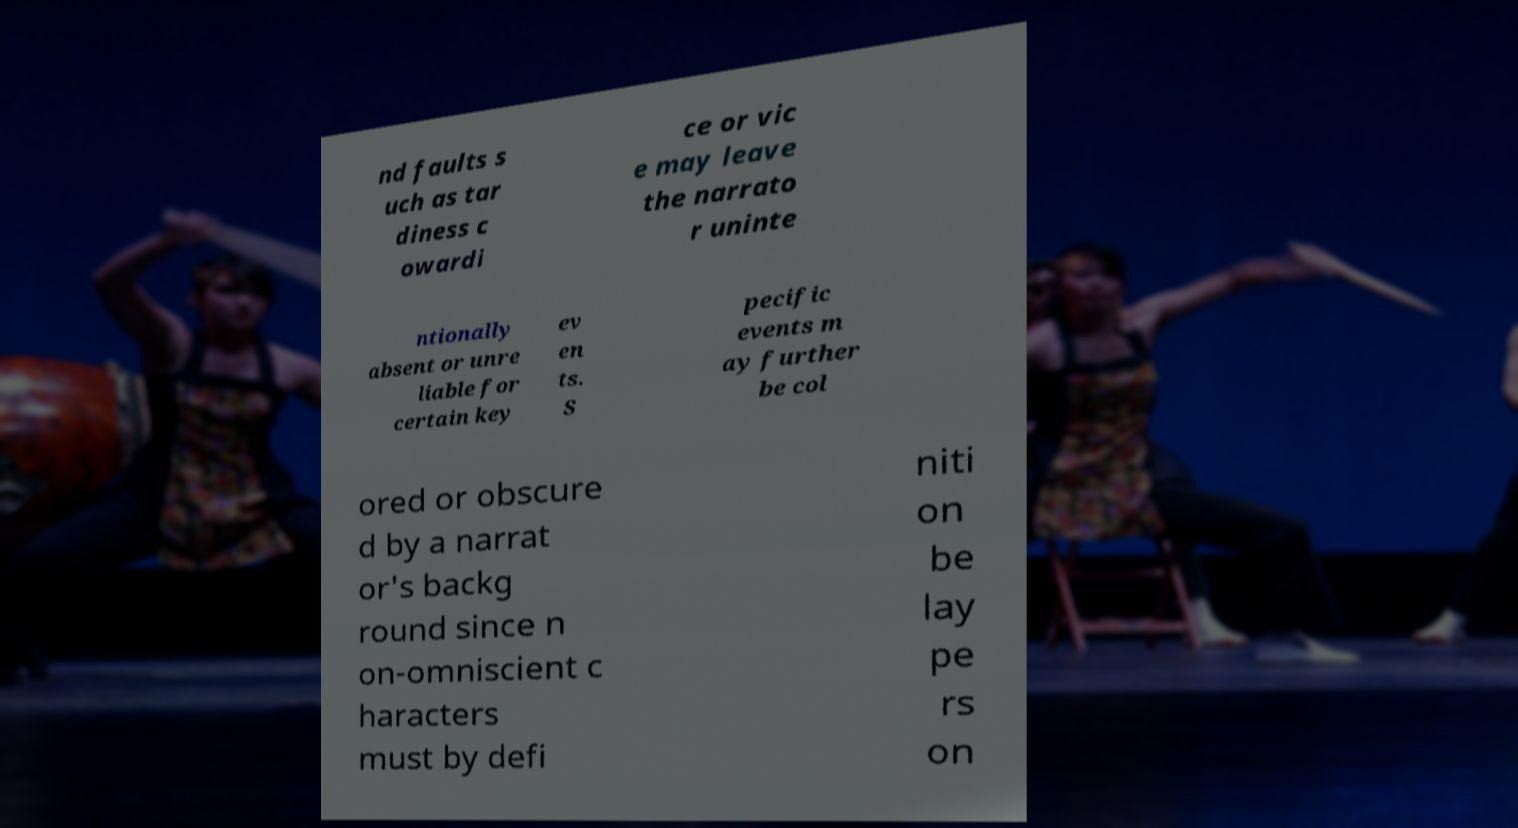I need the written content from this picture converted into text. Can you do that? nd faults s uch as tar diness c owardi ce or vic e may leave the narrato r uninte ntionally absent or unre liable for certain key ev en ts. S pecific events m ay further be col ored or obscure d by a narrat or's backg round since n on-omniscient c haracters must by defi niti on be lay pe rs on 